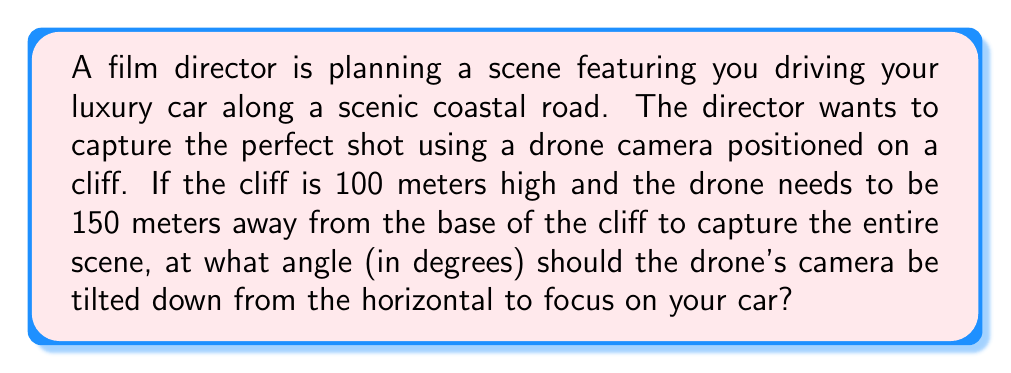Help me with this question. Let's approach this step-by-step using trigonometry:

1) We can visualize this scenario as a right triangle, where:
   - The vertical side is the height of the cliff (100 meters)
   - The horizontal side is the distance from the base of the cliff to the car (150 meters)
   - The hypotenuse is the line of sight from the drone to the car

2) We need to find the angle between the horizontal and the line of sight. This is the angle the camera should be tilted down.

3) In a right triangle, the tangent of an angle is the ratio of the opposite side to the adjacent side.

4) Let θ be the angle we're looking for. Then:

   $$\tan(\theta) = \frac{\text{opposite}}{\text{adjacent}} = \frac{100}{150}$$

5) To find θ, we need to take the inverse tangent (arctan or tan^(-1)) of both sides:

   $$\theta = \tan^{-1}(\frac{100}{150})$$

6) Using a calculator or computer:

   $$\theta = \tan^{-1}(\frac{2}{3}) \approx 33.69^\circ$$

7) Rounding to the nearest degree:

   $$\theta \approx 34^\circ$$

Therefore, the drone's camera should be tilted down approximately 34 degrees from the horizontal.
Answer: 34° 